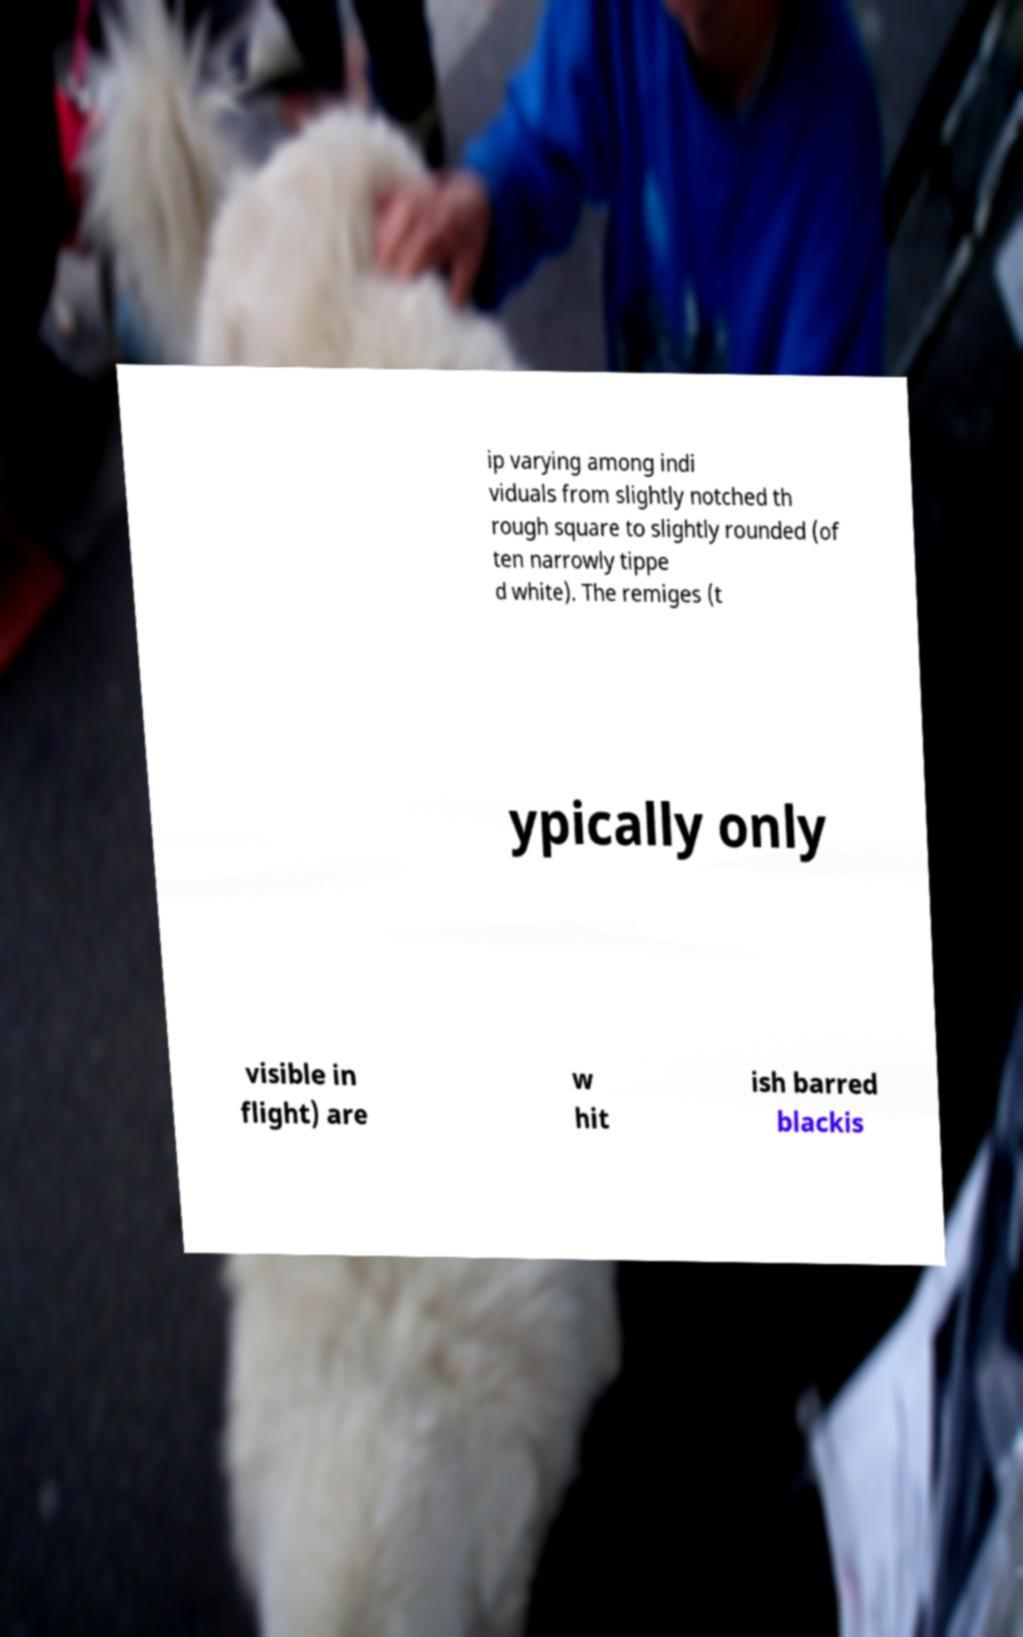Please read and relay the text visible in this image. What does it say? ip varying among indi viduals from slightly notched th rough square to slightly rounded (of ten narrowly tippe d white). The remiges (t ypically only visible in flight) are w hit ish barred blackis 